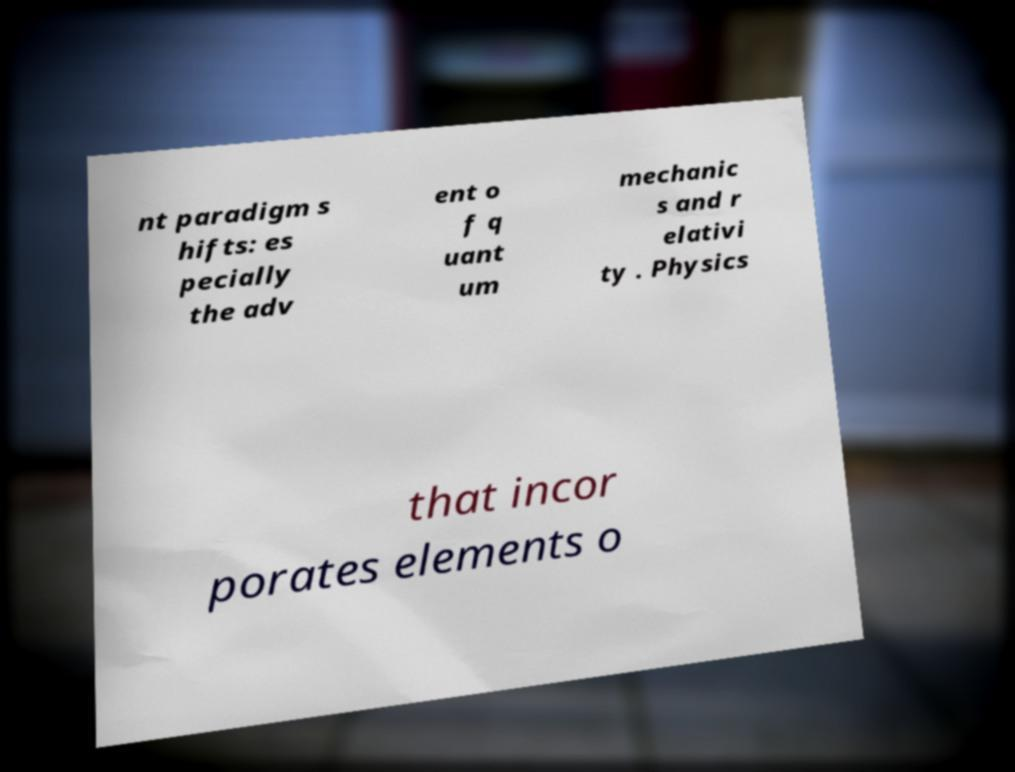Could you assist in decoding the text presented in this image and type it out clearly? nt paradigm s hifts: es pecially the adv ent o f q uant um mechanic s and r elativi ty . Physics that incor porates elements o 